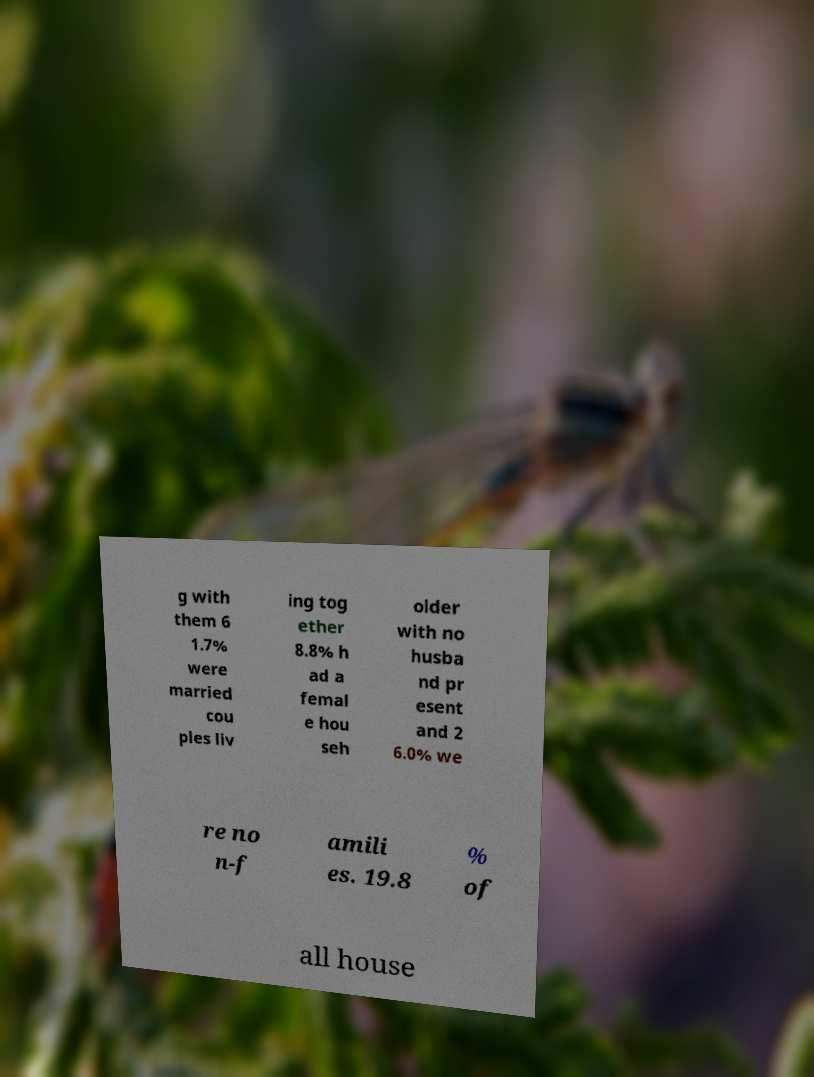Can you accurately transcribe the text from the provided image for me? g with them 6 1.7% were married cou ples liv ing tog ether 8.8% h ad a femal e hou seh older with no husba nd pr esent and 2 6.0% we re no n-f amili es. 19.8 % of all house 